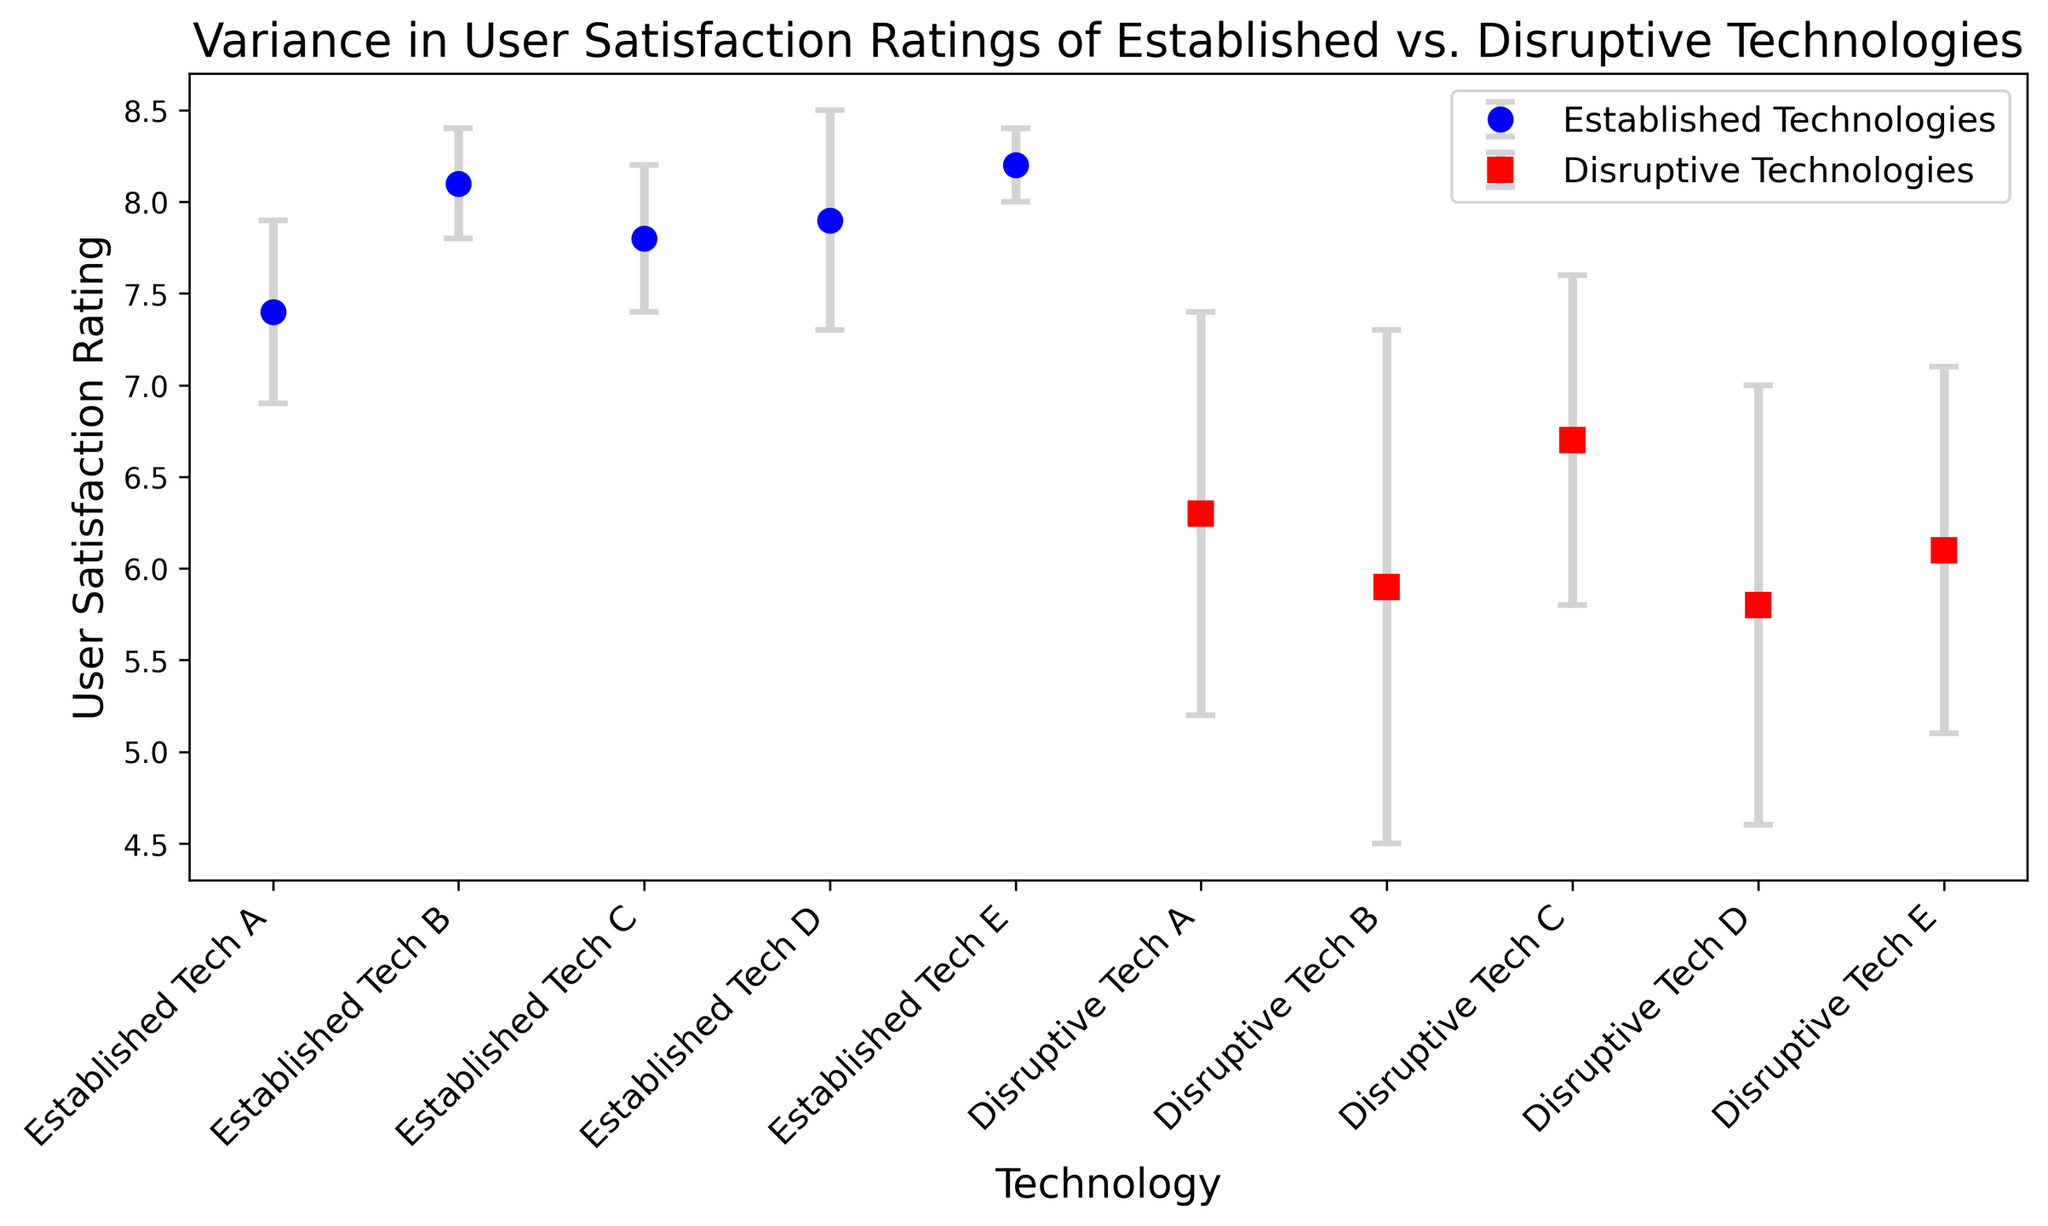What is the highest user satisfaction rating among disruptive technologies? From the figure, we can see that the highest dot among the disruptive technologies (represented by red squares) is Disruptive Tech C.
Answer: Disruptive Tech C (6.7) Which technology has the lowest user satisfaction rating variance among established technologies? The figure shows that established technologies (represented by blue circles) have different error bar lengths indicating variance. Established Tech E has the shortest error bar, indicating the lowest variance.
Answer: Established Tech E (0.2) What is the average user satisfaction rating of disruptive technologies? To find the average user satisfaction rating of disruptive technologies, sum the ratings 6.3, 5.9, 6.7, 5.8, 6.1 and divide by 5. (6.3 + 5.9 + 6.7 + 5.8 + 6.1) / 5 = 6.16.
Answer: 6.16 Which established technology has the highest user satisfaction rating, and what is its value? The figure shows different user satisfaction ratings for established technologies, with Established Tech E being the highest.
Answer: Established Tech E (8.2) Which type of technology displays greater variance in user satisfaction ratings overall, established or disruptive? From the error bars, it is evident that disruptive technologies (red squares) have larger error bars in general compared to established technologies (blue circles).
Answer: Disruptive Technologies By how much does the average user satisfaction rating of established technologies exceed that of disruptive technologies? First, calculate the average user satisfaction rating for both types:
Established: (7.4 + 8.1 + 7.8 + 7.9 + 8.2) / 5 = 7.88
Disruptive: (6.3 + 5.9 + 6.7 + 5.8 + 6.1) / 5 = 6.16
The difference is 7.88 - 6.16 = 1.72
Answer: 1.72 Identify the technology that has the greatest difference between its user satisfaction rating and its rating variance. Subtract the variance from the user rating for each technology:
Established: (6.9, 7.8, 7.4, 7.3, 8.0)
Disruptive: (5.2, 4.5, 5.8, 4.6, 5.1)
The maximum difference is for Established Tech E with 8.0.
Answer: Established Tech E What is the median user satisfaction rating for established technologies? List the ratings: 7.4, 7.8, 7.9, 8.1, 8.2. The median is the middle value of the sorted list, which is 7.9.
Answer: 7.9 